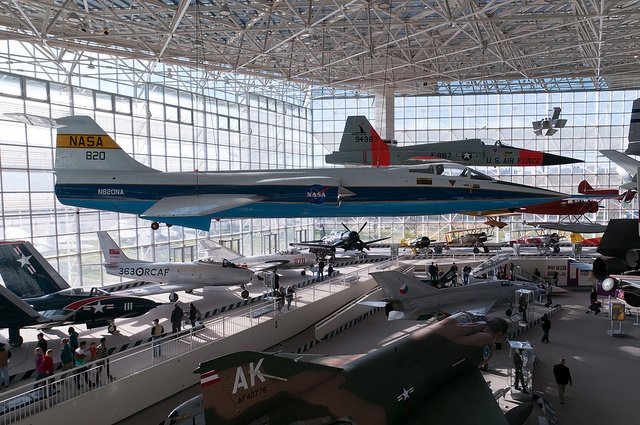Describe the objects in this image and their specific colors. I can see airplane in gray, black, darkblue, and blue tones, airplane in gray, black, and darkgray tones, airplane in gray, black, and darkblue tones, people in gray and black tones, and airplane in gray, black, purple, and maroon tones in this image. 